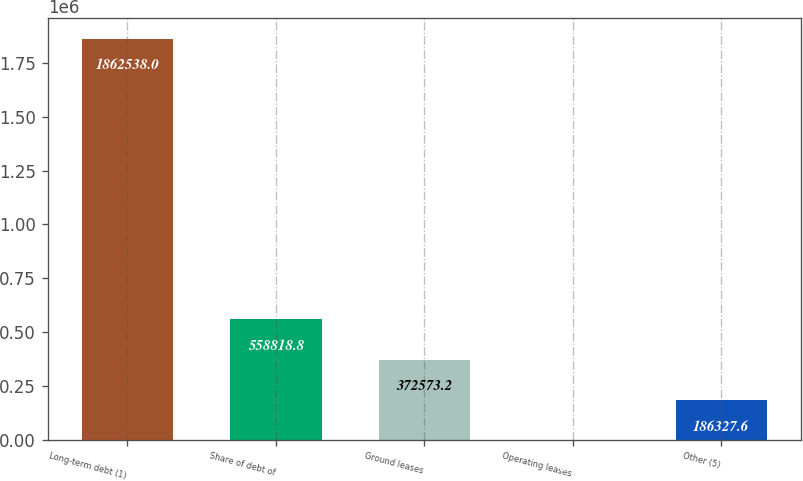<chart> <loc_0><loc_0><loc_500><loc_500><bar_chart><fcel>Long-term debt (1)<fcel>Share of debt of<fcel>Ground leases<fcel>Operating leases<fcel>Other (5)<nl><fcel>1.86254e+06<fcel>558819<fcel>372573<fcel>82<fcel>186328<nl></chart> 